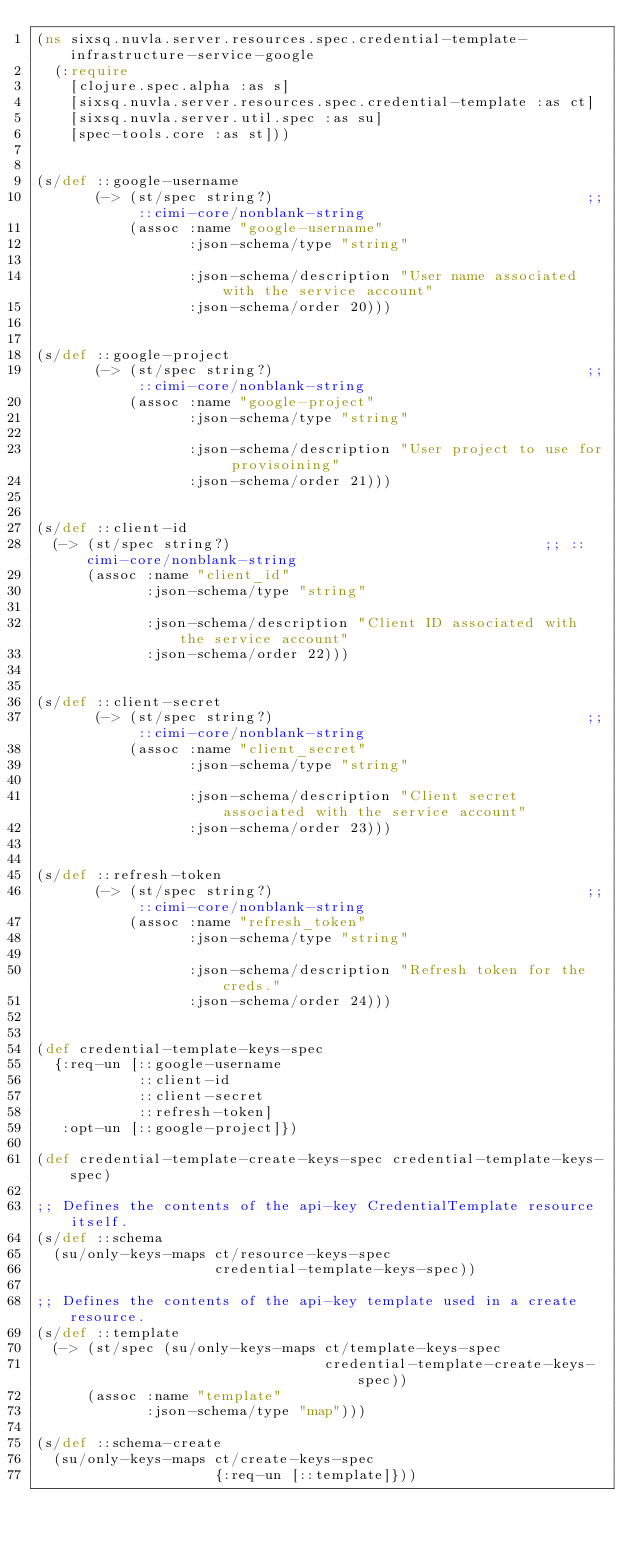<code> <loc_0><loc_0><loc_500><loc_500><_Clojure_>(ns sixsq.nuvla.server.resources.spec.credential-template-infrastructure-service-google
  (:require
    [clojure.spec.alpha :as s]
    [sixsq.nuvla.server.resources.spec.credential-template :as ct]
    [sixsq.nuvla.server.util.spec :as su]
    [spec-tools.core :as st]))


(s/def ::google-username
       (-> (st/spec string?)                                     ;; ::cimi-core/nonblank-string
           (assoc :name "google-username"
                  :json-schema/type "string"

                  :json-schema/description "User name associated with the service account"
                  :json-schema/order 20)))


(s/def ::google-project
       (-> (st/spec string?)                                     ;; ::cimi-core/nonblank-string
           (assoc :name "google-project"
                  :json-schema/type "string"

                  :json-schema/description "User project to use for provisoining"
                  :json-schema/order 21)))


(s/def ::client-id
  (-> (st/spec string?)                                     ;; ::cimi-core/nonblank-string
      (assoc :name "client_id"
             :json-schema/type "string"

             :json-schema/description "Client ID associated with the service account"
             :json-schema/order 22)))


(s/def ::client-secret
       (-> (st/spec string?)                                     ;; ::cimi-core/nonblank-string
           (assoc :name "client_secret"
                  :json-schema/type "string"

                  :json-schema/description "Client secret associated with the service account"
                  :json-schema/order 23)))


(s/def ::refresh-token
       (-> (st/spec string?)                                     ;; ::cimi-core/nonblank-string
           (assoc :name "refresh_token"
                  :json-schema/type "string"

                  :json-schema/description "Refresh token for the creds."
                  :json-schema/order 24)))


(def credential-template-keys-spec
  {:req-un [::google-username
            ::client-id
            ::client-secret
            ::refresh-token]
   :opt-un [::google-project]})

(def credential-template-create-keys-spec credential-template-keys-spec)

;; Defines the contents of the api-key CredentialTemplate resource itself.
(s/def ::schema
  (su/only-keys-maps ct/resource-keys-spec
                     credential-template-keys-spec))

;; Defines the contents of the api-key template used in a create resource.
(s/def ::template
  (-> (st/spec (su/only-keys-maps ct/template-keys-spec
                                  credential-template-create-keys-spec))
      (assoc :name "template"
             :json-schema/type "map")))

(s/def ::schema-create
  (su/only-keys-maps ct/create-keys-spec
                     {:req-un [::template]}))
</code> 